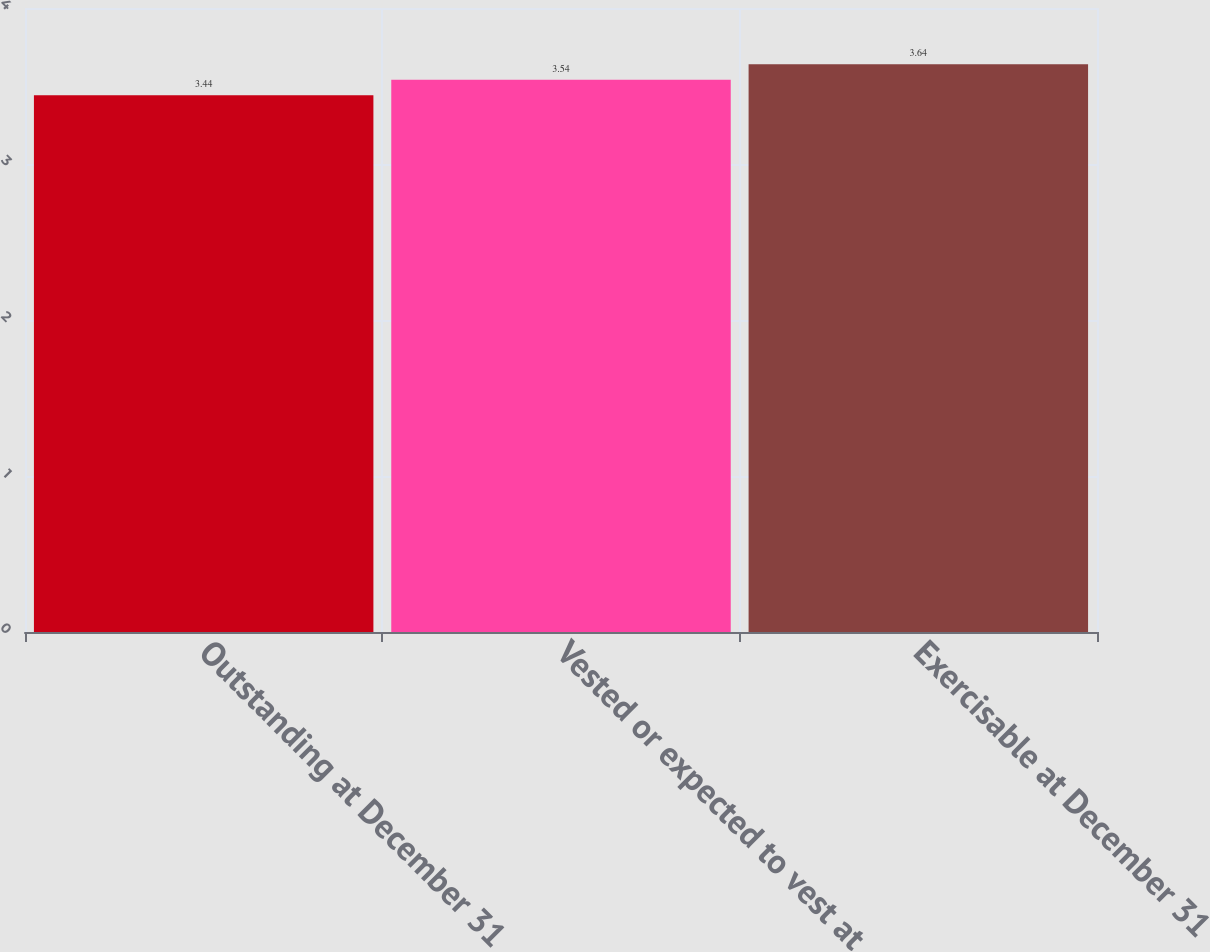Convert chart. <chart><loc_0><loc_0><loc_500><loc_500><bar_chart><fcel>Outstanding at December 31<fcel>Vested or expected to vest at<fcel>Exercisable at December 31<nl><fcel>3.44<fcel>3.54<fcel>3.64<nl></chart> 